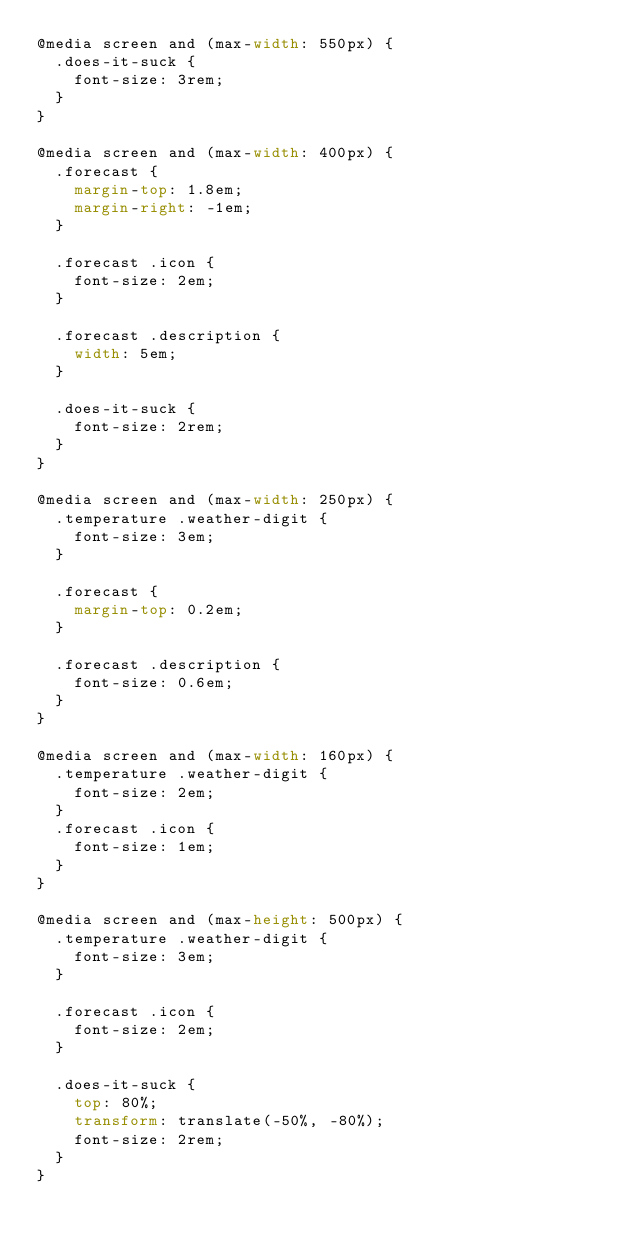<code> <loc_0><loc_0><loc_500><loc_500><_CSS_>@media screen and (max-width: 550px) {
  .does-it-suck {
    font-size: 3rem;
  }
}

@media screen and (max-width: 400px) {
  .forecast {
    margin-top: 1.8em;
    margin-right: -1em;
  }

  .forecast .icon {
    font-size: 2em;
  }

  .forecast .description {
    width: 5em;
  }

  .does-it-suck {
    font-size: 2rem;
  }
}

@media screen and (max-width: 250px) {
  .temperature .weather-digit {
    font-size: 3em;
  }

  .forecast {
    margin-top: 0.2em;
  }

  .forecast .description {
    font-size: 0.6em;
  }
}

@media screen and (max-width: 160px) {
  .temperature .weather-digit {
    font-size: 2em;
  }
  .forecast .icon {
    font-size: 1em;
  }
}

@media screen and (max-height: 500px) {
  .temperature .weather-digit {
    font-size: 3em;
  }

  .forecast .icon {
    font-size: 2em;
  }

  .does-it-suck {
    top: 80%;
    transform: translate(-50%, -80%);
    font-size: 2rem;
  }
}
</code> 